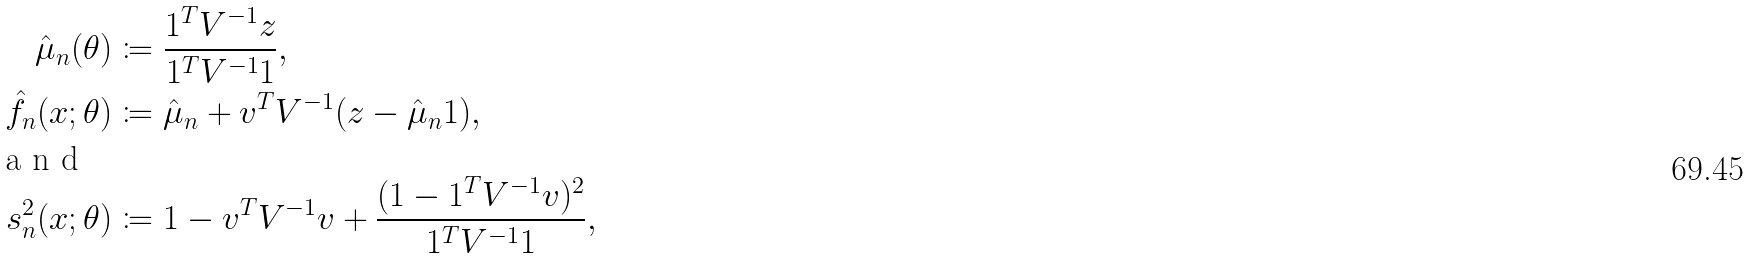Convert formula to latex. <formula><loc_0><loc_0><loc_500><loc_500>\hat { \mu } _ { n } ( \theta ) & \coloneqq \frac { 1 ^ { T } V ^ { - 1 } z } { 1 ^ { T } V ^ { - 1 } 1 } , \\ \hat { f } _ { n } ( x ; \theta ) & \coloneqq \hat { \mu } _ { n } + v ^ { T } V ^ { - 1 } ( z - \hat { \mu } _ { n } 1 ) , \\ \shortintertext { a n d } s ^ { 2 } _ { n } ( x ; \theta ) & \coloneqq 1 - v ^ { T } V ^ { - 1 } v + \frac { ( 1 - 1 ^ { T } V ^ { - 1 } v ) ^ { 2 } } { 1 ^ { T } V ^ { - 1 } 1 } ,</formula> 